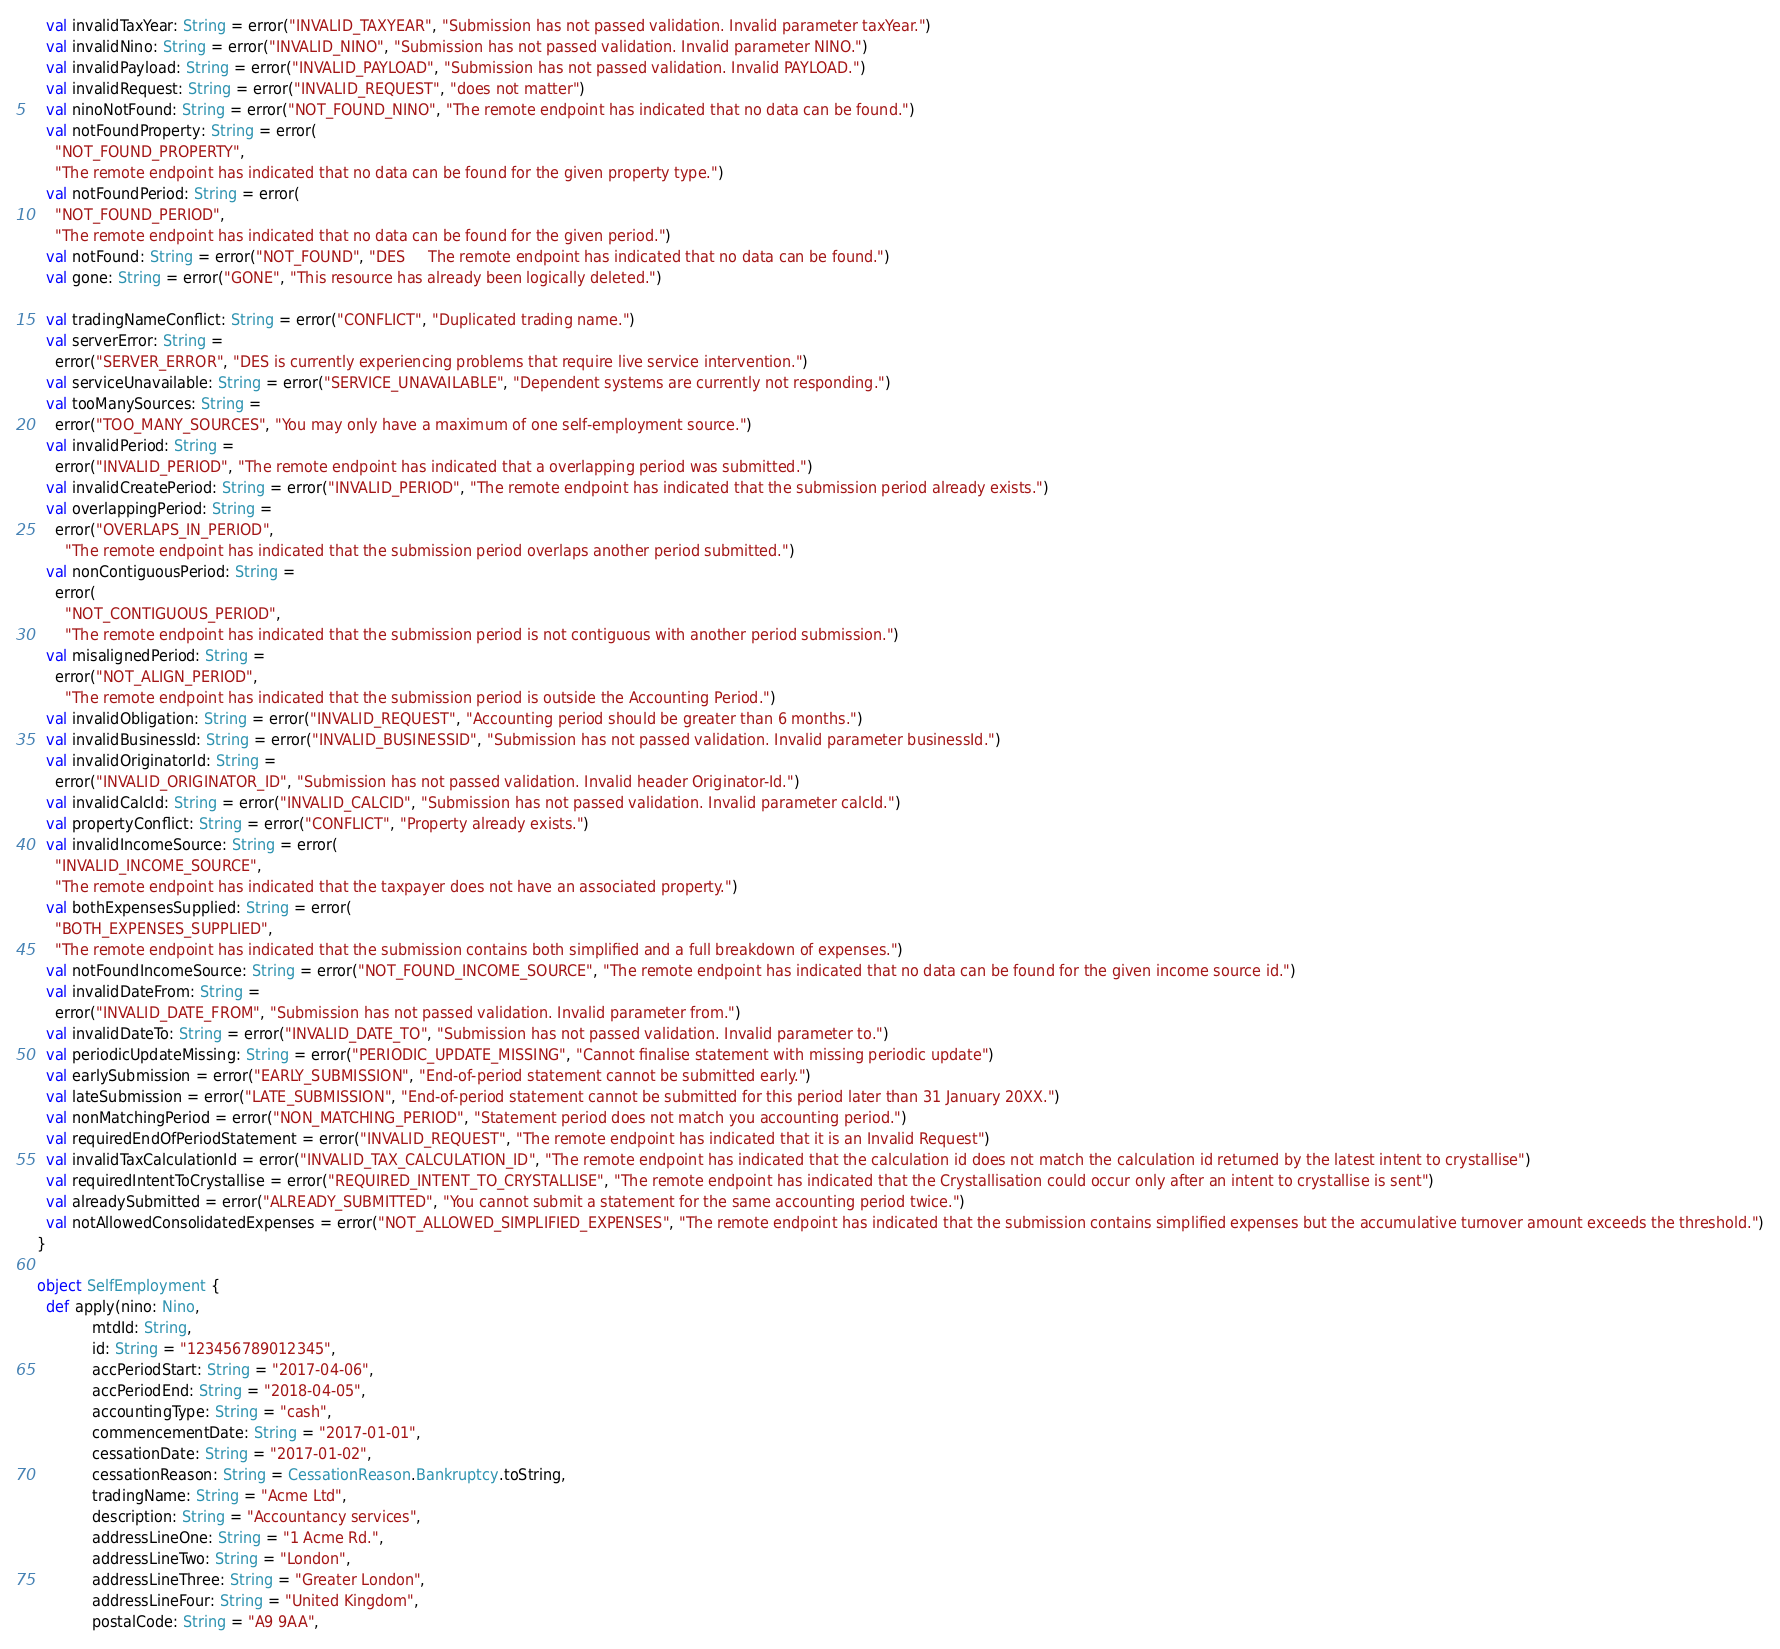Convert code to text. <code><loc_0><loc_0><loc_500><loc_500><_Scala_>    val invalidTaxYear: String = error("INVALID_TAXYEAR", "Submission has not passed validation. Invalid parameter taxYear.")
    val invalidNino: String = error("INVALID_NINO", "Submission has not passed validation. Invalid parameter NINO.")
    val invalidPayload: String = error("INVALID_PAYLOAD", "Submission has not passed validation. Invalid PAYLOAD.")
    val invalidRequest: String = error("INVALID_REQUEST", "does not matter")
    val ninoNotFound: String = error("NOT_FOUND_NINO", "The remote endpoint has indicated that no data can be found.")
    val notFoundProperty: String = error(
      "NOT_FOUND_PROPERTY",
      "The remote endpoint has indicated that no data can be found for the given property type.")
    val notFoundPeriod: String = error(
      "NOT_FOUND_PERIOD",
      "The remote endpoint has indicated that no data can be found for the given period.")
    val notFound: String = error("NOT_FOUND", "DES     The remote endpoint has indicated that no data can be found.")
    val gone: String = error("GONE", "This resource has already been logically deleted.")

    val tradingNameConflict: String = error("CONFLICT", "Duplicated trading name.")
    val serverError: String =
      error("SERVER_ERROR", "DES is currently experiencing problems that require live service intervention.")
    val serviceUnavailable: String = error("SERVICE_UNAVAILABLE", "Dependent systems are currently not responding.")
    val tooManySources: String =
      error("TOO_MANY_SOURCES", "You may only have a maximum of one self-employment source.")
    val invalidPeriod: String =
      error("INVALID_PERIOD", "The remote endpoint has indicated that a overlapping period was submitted.")
    val invalidCreatePeriod: String = error("INVALID_PERIOD", "The remote endpoint has indicated that the submission period already exists.")
    val overlappingPeriod: String =
      error("OVERLAPS_IN_PERIOD",
        "The remote endpoint has indicated that the submission period overlaps another period submitted.")
    val nonContiguousPeriod: String =
      error(
        "NOT_CONTIGUOUS_PERIOD",
        "The remote endpoint has indicated that the submission period is not contiguous with another period submission.")
    val misalignedPeriod: String =
      error("NOT_ALIGN_PERIOD",
        "The remote endpoint has indicated that the submission period is outside the Accounting Period.")
    val invalidObligation: String = error("INVALID_REQUEST", "Accounting period should be greater than 6 months.")
    val invalidBusinessId: String = error("INVALID_BUSINESSID", "Submission has not passed validation. Invalid parameter businessId.")
    val invalidOriginatorId: String =
      error("INVALID_ORIGINATOR_ID", "Submission has not passed validation. Invalid header Originator-Id.")
    val invalidCalcId: String = error("INVALID_CALCID", "Submission has not passed validation. Invalid parameter calcId.")
    val propertyConflict: String = error("CONFLICT", "Property already exists.")
    val invalidIncomeSource: String = error(
      "INVALID_INCOME_SOURCE",
      "The remote endpoint has indicated that the taxpayer does not have an associated property.")
    val bothExpensesSupplied: String = error(
      "BOTH_EXPENSES_SUPPLIED",
      "The remote endpoint has indicated that the submission contains both simplified and a full breakdown of expenses.")
    val notFoundIncomeSource: String = error("NOT_FOUND_INCOME_SOURCE", "The remote endpoint has indicated that no data can be found for the given income source id.")
    val invalidDateFrom: String =
      error("INVALID_DATE_FROM", "Submission has not passed validation. Invalid parameter from.")
    val invalidDateTo: String = error("INVALID_DATE_TO", "Submission has not passed validation. Invalid parameter to.")
    val periodicUpdateMissing: String = error("PERIODIC_UPDATE_MISSING", "Cannot finalise statement with missing periodic update")
    val earlySubmission = error("EARLY_SUBMISSION", "End-of-period statement cannot be submitted early.")
    val lateSubmission = error("LATE_SUBMISSION", "End-of-period statement cannot be submitted for this period later than 31 January 20XX.")
    val nonMatchingPeriod = error("NON_MATCHING_PERIOD", "Statement period does not match you accounting period.")
    val requiredEndOfPeriodStatement = error("INVALID_REQUEST", "The remote endpoint has indicated that it is an Invalid Request")
    val invalidTaxCalculationId = error("INVALID_TAX_CALCULATION_ID", "The remote endpoint has indicated that the calculation id does not match the calculation id returned by the latest intent to crystallise")
    val requiredIntentToCrystallise = error("REQUIRED_INTENT_TO_CRYSTALLISE", "The remote endpoint has indicated that the Crystallisation could occur only after an intent to crystallise is sent")
    val alreadySubmitted = error("ALREADY_SUBMITTED", "You cannot submit a statement for the same accounting period twice.")
    val notAllowedConsolidatedExpenses = error("NOT_ALLOWED_SIMPLIFIED_EXPENSES", "The remote endpoint has indicated that the submission contains simplified expenses but the accumulative turnover amount exceeds the threshold.")
  }

  object SelfEmployment {
    def apply(nino: Nino,
              mtdId: String,
              id: String = "123456789012345",
              accPeriodStart: String = "2017-04-06",
              accPeriodEnd: String = "2018-04-05",
              accountingType: String = "cash",
              commencementDate: String = "2017-01-01",
              cessationDate: String = "2017-01-02",
              cessationReason: String = CessationReason.Bankruptcy.toString,
              tradingName: String = "Acme Ltd",
              description: String = "Accountancy services",
              addressLineOne: String = "1 Acme Rd.",
              addressLineTwo: String = "London",
              addressLineThree: String = "Greater London",
              addressLineFour: String = "United Kingdom",
              postalCode: String = "A9 9AA",</code> 